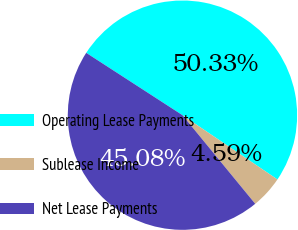Convert chart. <chart><loc_0><loc_0><loc_500><loc_500><pie_chart><fcel>Operating Lease Payments<fcel>Sublease Income<fcel>Net Lease Payments<nl><fcel>50.32%<fcel>4.59%<fcel>45.08%<nl></chart> 